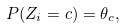Convert formula to latex. <formula><loc_0><loc_0><loc_500><loc_500>P ( Z _ { i } = c ) = \theta _ { c } ,</formula> 